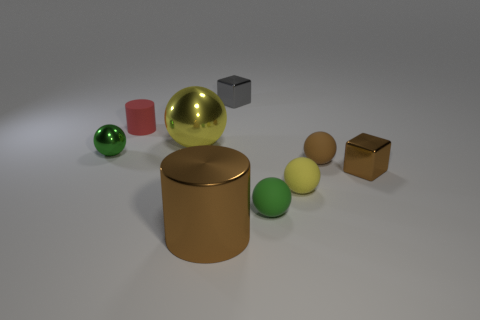What number of other things are the same color as the small cylinder?
Your answer should be compact. 0. Does the brown shiny thing right of the brown rubber ball have the same size as the green sphere that is to the right of the brown metallic cylinder?
Give a very brief answer. Yes. Do the small gray thing and the yellow sphere left of the large brown metal cylinder have the same material?
Your answer should be very brief. Yes. Are there more small cylinders that are on the right side of the gray metal object than small rubber objects behind the tiny green matte object?
Provide a succinct answer. No. What color is the small block right of the cube that is behind the yellow metal ball?
Keep it short and to the point. Brown. What number of cylinders are either gray things or red objects?
Ensure brevity in your answer.  1. What number of small objects are both to the right of the tiny red cylinder and in front of the gray metallic cube?
Your response must be concise. 4. There is a shiny block that is on the right side of the brown rubber ball; what is its color?
Make the answer very short. Brown. What size is the cylinder that is made of the same material as the small yellow object?
Ensure brevity in your answer.  Small. There is a yellow ball that is right of the tiny gray object; what number of brown metallic cylinders are on the left side of it?
Keep it short and to the point. 1. 